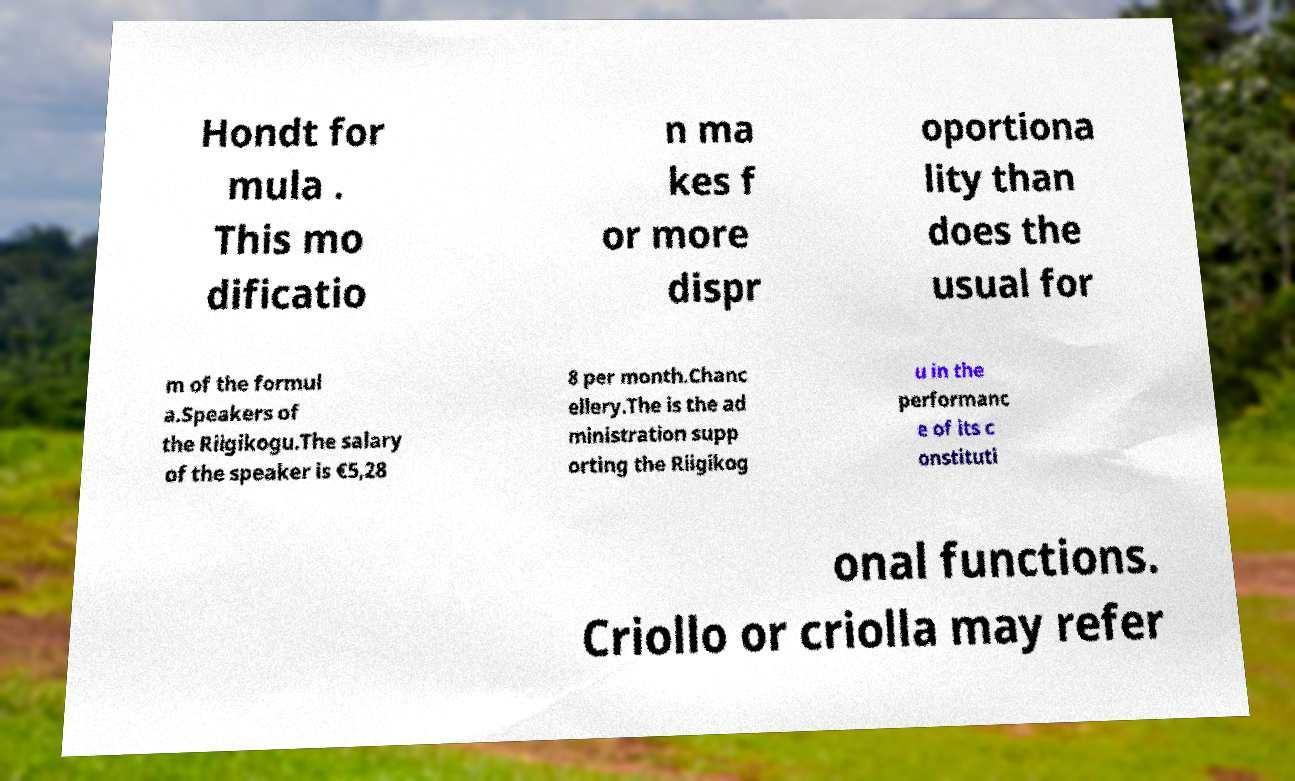Please identify and transcribe the text found in this image. Hondt for mula . This mo dificatio n ma kes f or more dispr oportiona lity than does the usual for m of the formul a.Speakers of the Riigikogu.The salary of the speaker is €5,28 8 per month.Chanc ellery.The is the ad ministration supp orting the Riigikog u in the performanc e of its c onstituti onal functions. Criollo or criolla may refer 